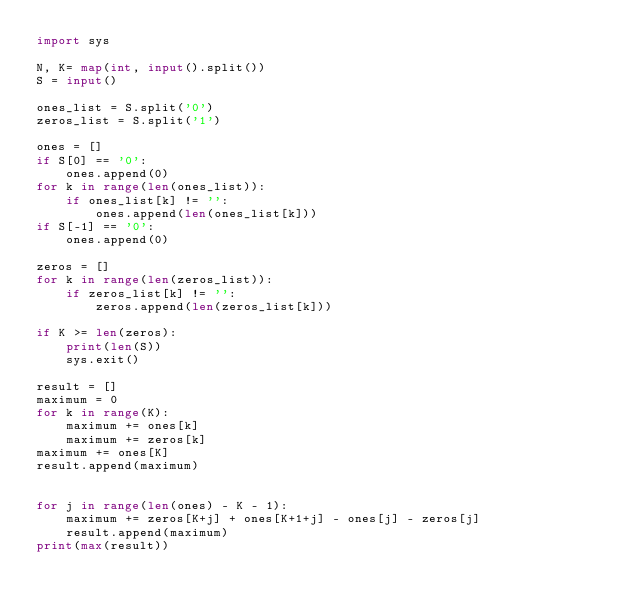Convert code to text. <code><loc_0><loc_0><loc_500><loc_500><_Python_>import sys

N, K= map(int, input().split())
S = input()

ones_list = S.split('0')
zeros_list = S.split('1')

ones = []
if S[0] == '0':
    ones.append(0)
for k in range(len(ones_list)):
    if ones_list[k] != '':
        ones.append(len(ones_list[k]))
if S[-1] == '0':
    ones.append(0)

zeros = []
for k in range(len(zeros_list)):
    if zeros_list[k] != '':
        zeros.append(len(zeros_list[k]))

if K >= len(zeros):
    print(len(S))
    sys.exit()

result = []
maximum = 0
for k in range(K):
    maximum += ones[k]
    maximum += zeros[k]
maximum += ones[K]
result.append(maximum)


for j in range(len(ones) - K - 1):
    maximum += zeros[K+j] + ones[K+1+j] - ones[j] - zeros[j]
    result.append(maximum)
print(max(result))</code> 